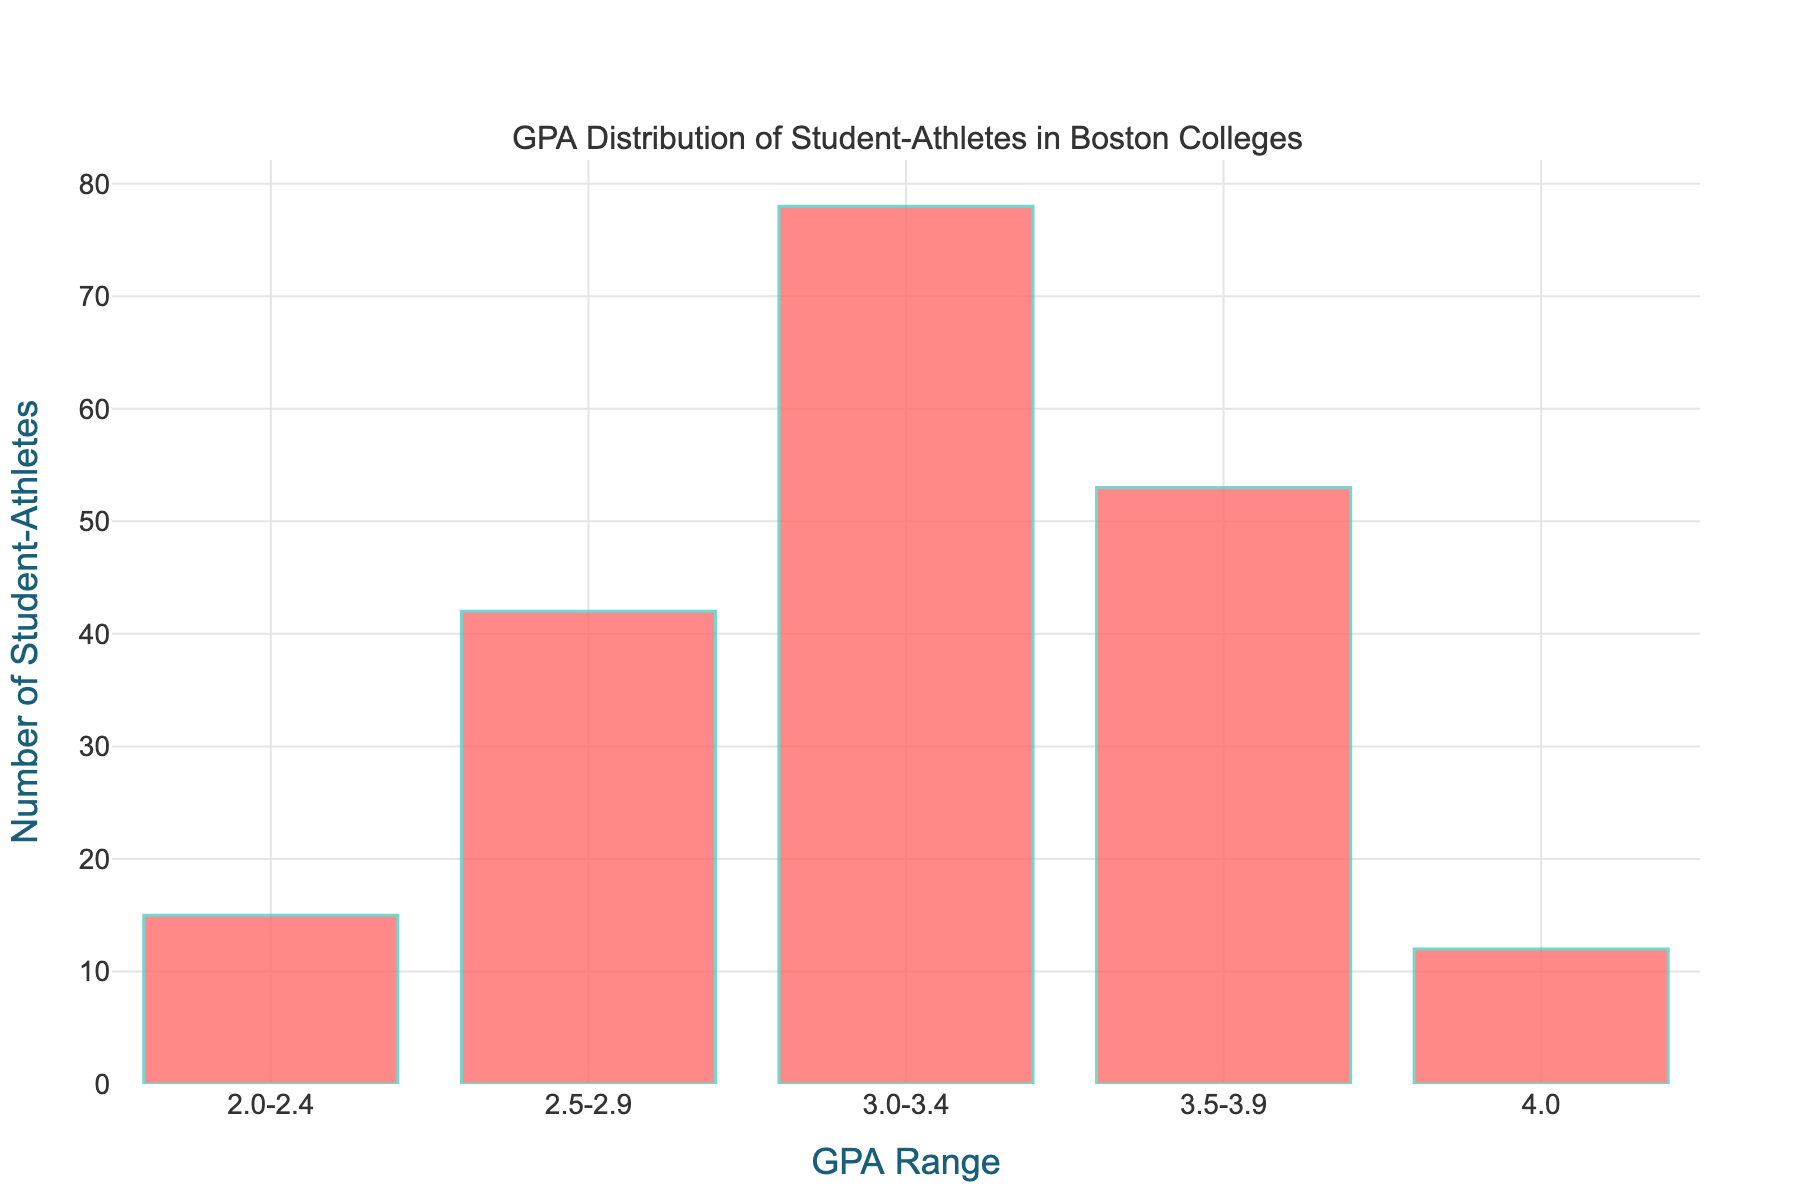What is the title of the histogram? The title of the histogram is located at the top and it describes the content of the chart.
Answer: GPA Distribution of Student-Athletes in Boston Colleges What is the highest number of student-athletes in a GPA range? To find the highest number of student-athletes, look for the tallest bar in the histogram.
Answer: 78 How many GPA ranges are depicted in the histogram? Count the number of bars in the histogram. Each bar represents a GPA range.
Answer: 5 Which GPA range has the least number of student-athletes? Identify the shortest bar in the histogram, which represents the GPA range with the least student-athletes.
Answer: 4.0 What is the total number of student-athletes represented in the histogram? Add up the numbers of student-athletes from all GPA ranges: 15 + 42 + 78 + 53 + 12.
Answer: 200 What is the comparison between the number of student-athletes in the 3.0-3.4 range and the 2.0-2.4 range? Compare the heights of the bars for the 3.0-3.4 range (78) and the 2.0-2.4 range (15).
Answer: 3.0-3.4 range has 63 more student-athletes than the 2.0-2.4 range What is the average number of student-athletes per GPA range? Add the total number of student-athletes in all GPA ranges and divide by the number of GPA ranges: 200 / 5.
Answer: 40 How does the number of student-athletes in the 3.5-3.9 GPA range compare to those in the 2.5-2.9 GPA range? Compare the heights of the bars for the 3.5-3.9 range (53) and the 2.5-2.9 range (42).
Answer: 3.5-3.9 range has 11 more student-athletes What percentage of student-athletes have a GPA in the 3.0-3.4 range? Calculate the percentage by dividing the number of student-athletes in 3.0-3.4 range by the total number and multiply by 100: (78 / 200) * 100.
Answer: 39% Which GPA range has the most significant number of student-athletes, and how many are there exactly? Identify the tallest bar in the histogram representing the GPA range with the most significant number of student-athletes.
Answer: 3.0-3.4, 78 